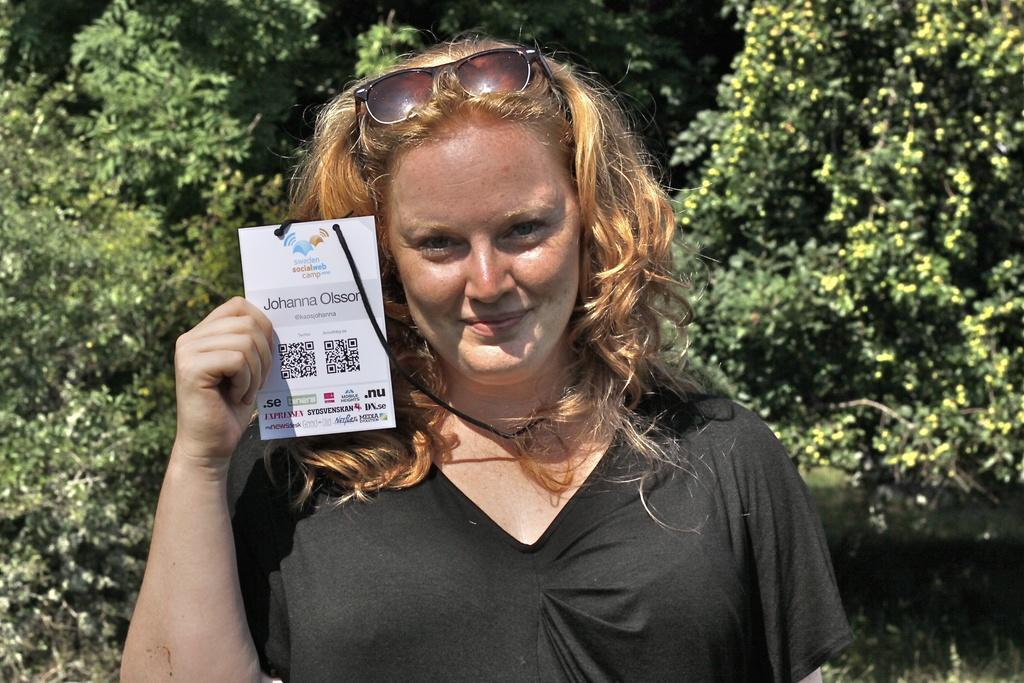Who is present in the image? There is a woman in the image. What is the woman holding in her hand? The woman is holding a card in her hand. What is on the woman's head? There is a Google logo on the woman's head. What can be seen in the background of the image? There are trees in the background of the image. What type of drink is the woman sipping in the image? There is no drink present in the image; the woman is holding a card and has a Google logo on her head. 